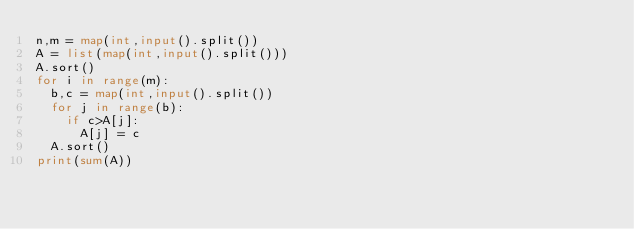<code> <loc_0><loc_0><loc_500><loc_500><_Python_>n,m = map(int,input().split())
A = list(map(int,input().split()))
A.sort()
for i in range(m):
  b,c = map(int,input().split())
  for j in range(b):
    if c>A[j]:
      A[j] = c
  A.sort()
print(sum(A))</code> 